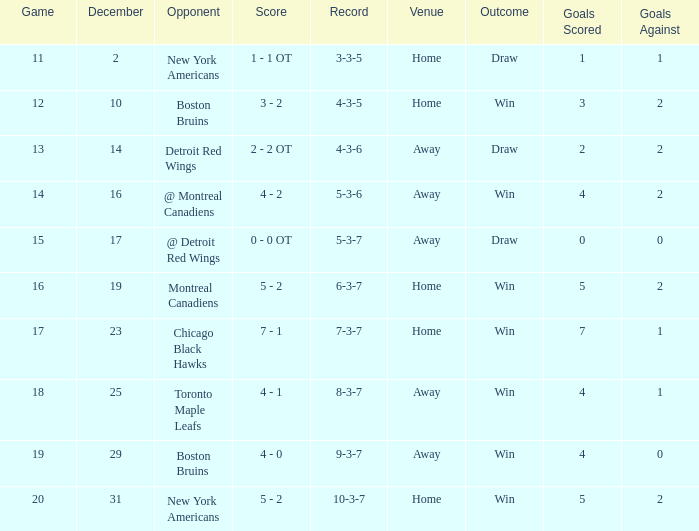Which December has a Record of 4-3-6? 14.0. 